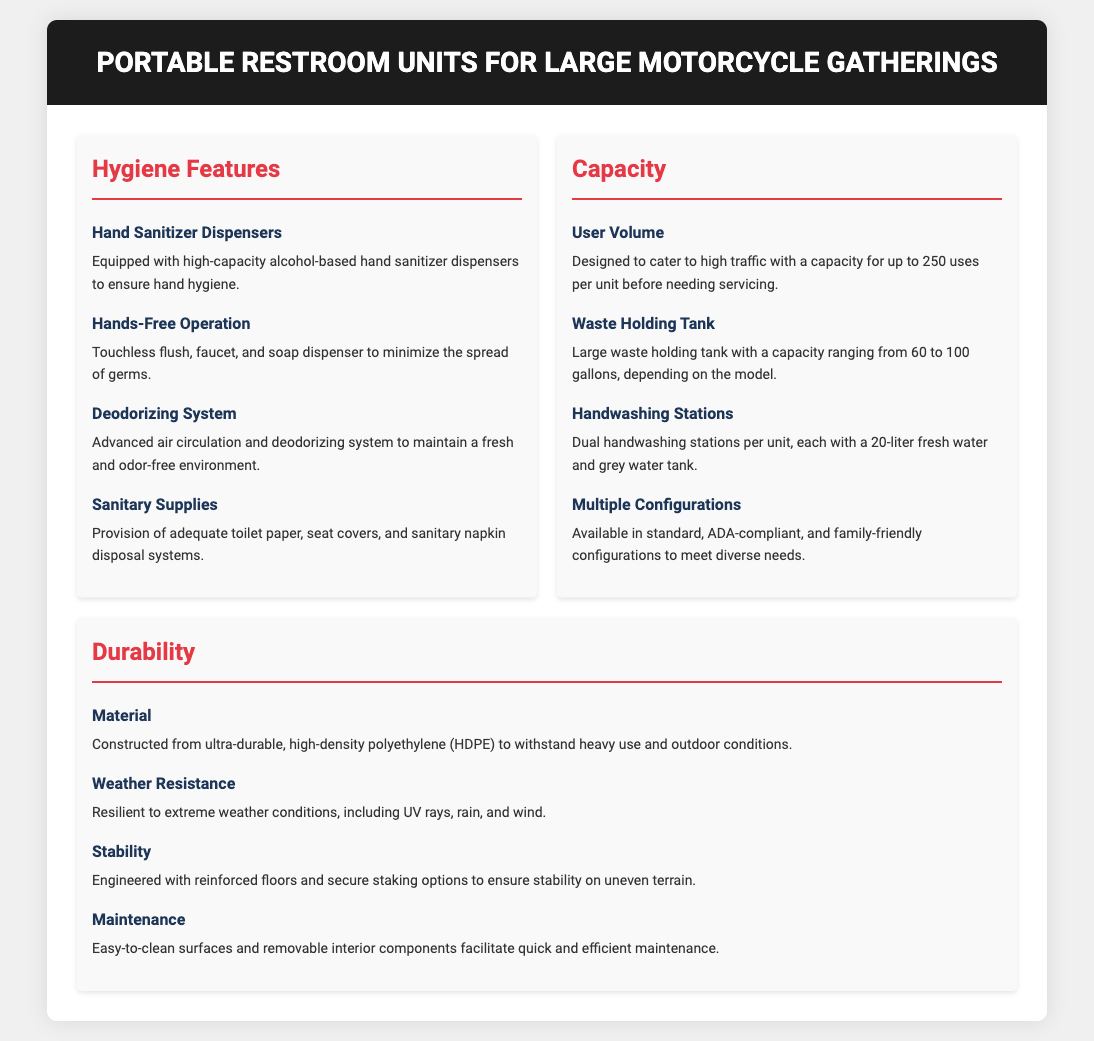what hygiene feature ensures hand cleanliness? The portable restroom units are equipped with high-capacity alcohol-based hand sanitizer dispensers to ensure hand hygiene.
Answer: Hand Sanitizer Dispensers what is the user volume capacity per unit? The document states that the units are designed to cater to high traffic with a capacity for up to 250 uses per unit before needing servicing.
Answer: 250 uses what material are the units constructed from? The document specifies that the units are constructed from ultra-durable, high-density polyethylene (HDPE) to withstand heavy use and outdoor conditions.
Answer: HDPE how many gallons can the waste holding tank hold? It mentions that the waste holding tank has a capacity ranging from 60 to 100 gallons, depending on the model.
Answer: 60 to 100 gallons what are the handwashing stations' water tank capacities? The document specifies that each handwashing station has a 20-liter fresh water and grey water tank.
Answer: 20 liters what system maintains a fresh environment? The document describes an advanced air circulation and deodorizing system that maintains a fresh and odor-free environment.
Answer: Deodorizing System what is a feature for minimizing germ spread? The document states that the units have touchless flush, faucet, and soap dispenser to minimize the spread of germs.
Answer: Hands-Free Operation what configurations are available for the units? The portable restroom units are available in standard, ADA-compliant, and family-friendly configurations to meet diverse needs.
Answer: Standard, ADA-compliant, and family-friendly what provides stability on uneven terrain? The document describes that the units are engineered with reinforced floors and secure staking options to ensure stability on uneven terrain.
Answer: Reinforced floors and secure staking options 